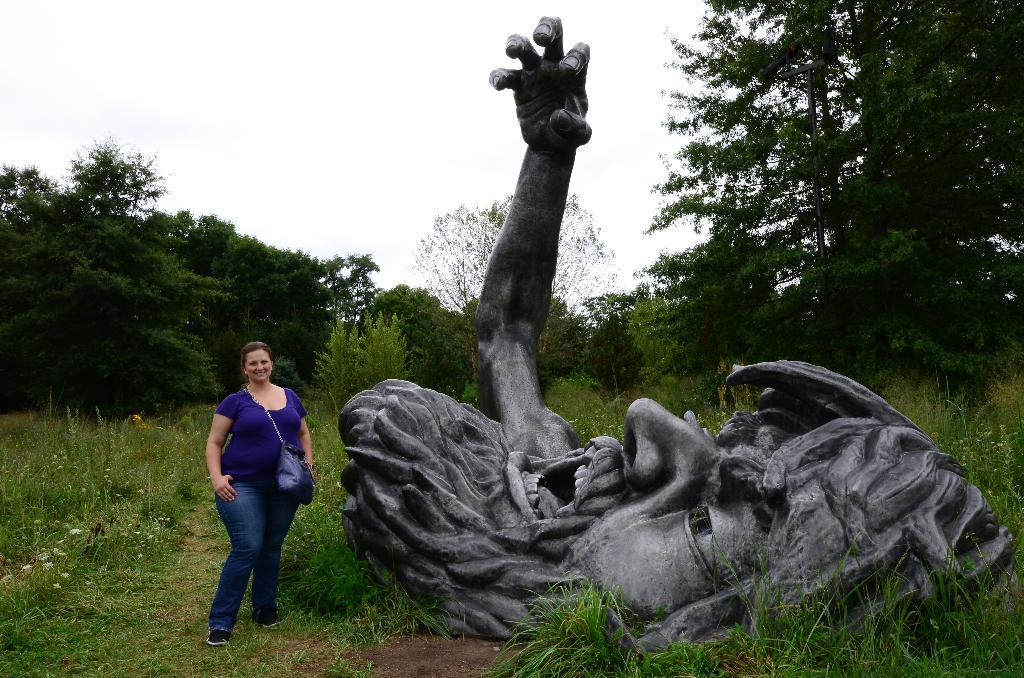Who is present in the image? There is a lady in the image. What is the lady standing beside? The lady is standing beside a sculpture. What type of natural environment is visible in the image? There is grass and trees in the image. What is the lady writing on the chain in the image? There is no chain or writing present in the image. 